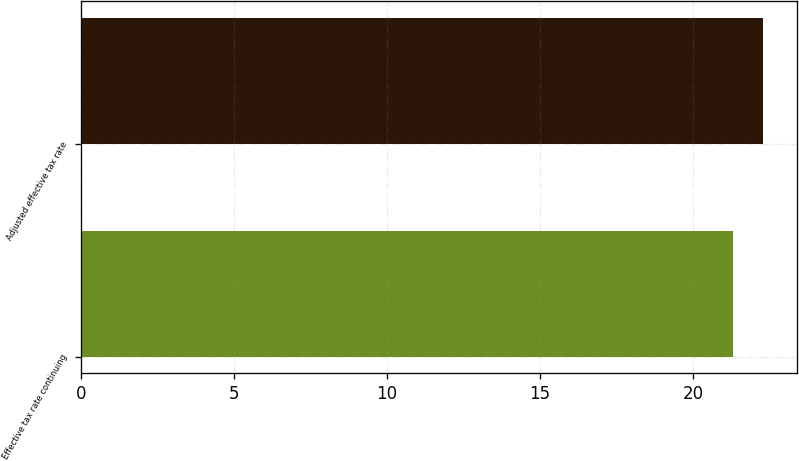<chart> <loc_0><loc_0><loc_500><loc_500><bar_chart><fcel>Effective tax rate continuing<fcel>Adjusted effective tax rate<nl><fcel>21.3<fcel>22.3<nl></chart> 